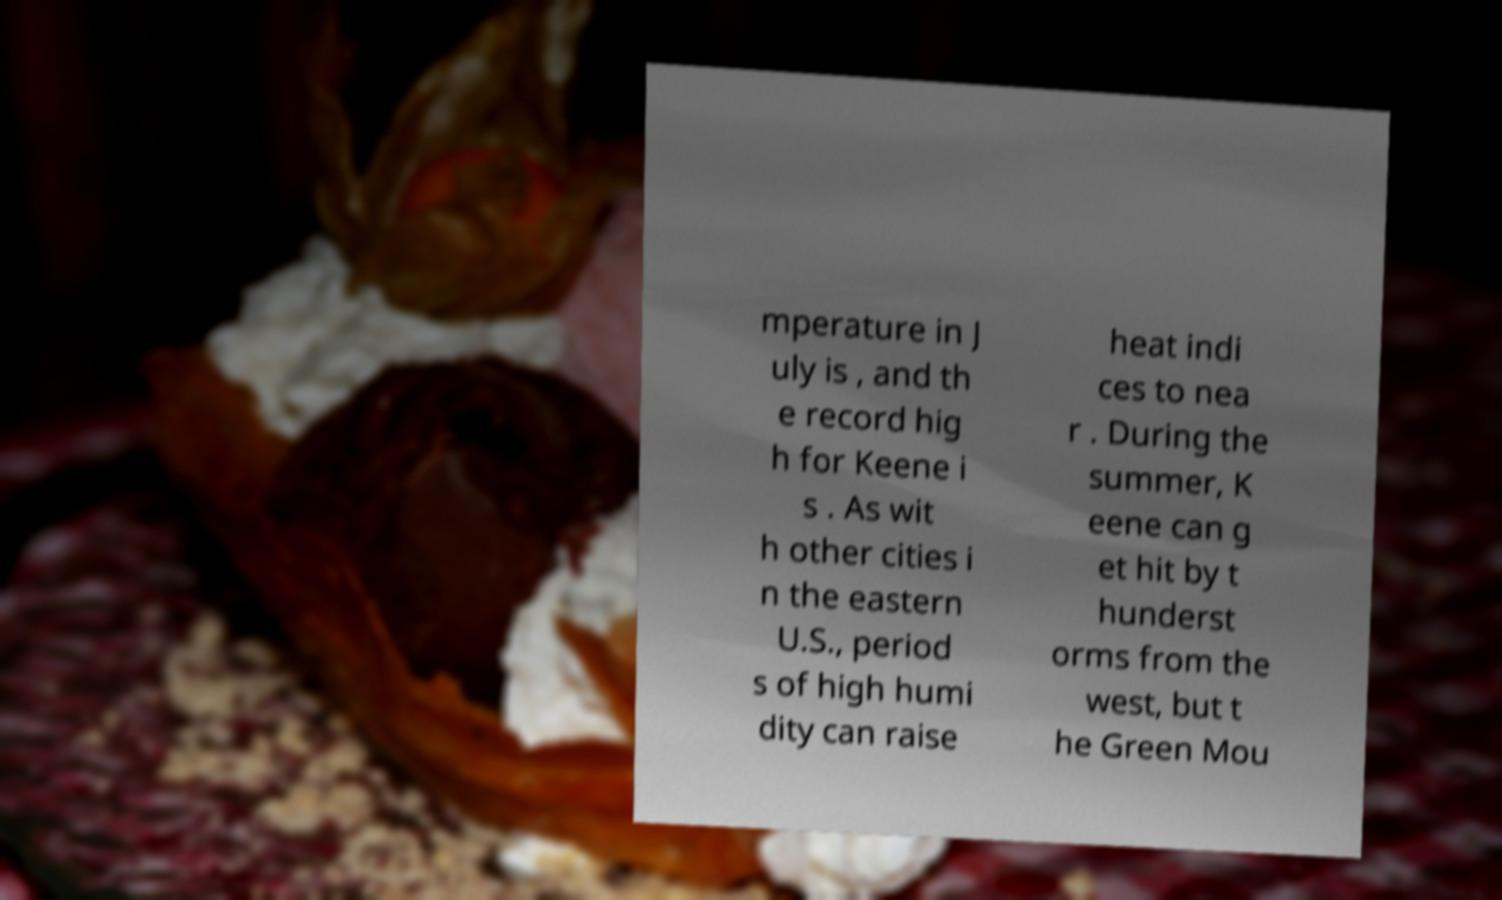Could you extract and type out the text from this image? mperature in J uly is , and th e record hig h for Keene i s . As wit h other cities i n the eastern U.S., period s of high humi dity can raise heat indi ces to nea r . During the summer, K eene can g et hit by t hunderst orms from the west, but t he Green Mou 